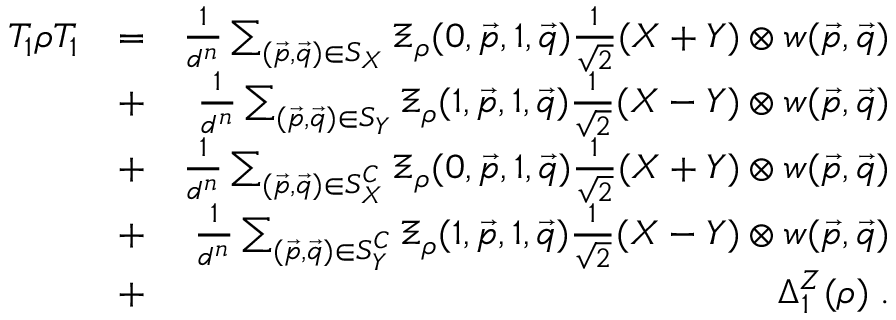<formula> <loc_0><loc_0><loc_500><loc_500>\begin{array} { r l r } { T _ { 1 } \rho T _ { 1 } } & { = } & { \frac { 1 } { d ^ { n } } \sum _ { ( \vec { p } , \vec { q } ) \in S _ { X } } \Xi _ { \rho } ( 0 , \vec { p } , 1 , \vec { q } ) \frac { 1 } { \sqrt { 2 } } ( X + Y ) \otimes w ( \vec { p } , \vec { q } ) } \\ & { + } & { \frac { 1 } { d ^ { n } } \sum _ { ( \vec { p } , \vec { q } ) \in S _ { Y } } \Xi _ { \rho } ( 1 , \vec { p } , 1 , \vec { q } ) \frac { 1 } { \sqrt { 2 } } ( X - Y ) \otimes w ( \vec { p } , \vec { q } ) } \\ & { + } & { \frac { 1 } { d ^ { n } } \sum _ { ( \vec { p } , \vec { q } ) \in S _ { X } ^ { C } } \Xi _ { \rho } ( 0 , \vec { p } , 1 , \vec { q } ) \frac { 1 } { \sqrt { 2 } } ( X + Y ) \otimes w ( \vec { p } , \vec { q } ) } \\ & { + } & { \frac { 1 } { d ^ { n } } \sum _ { ( \vec { p } , \vec { q } ) \in S _ { Y } ^ { C } } \Xi _ { \rho } ( 1 , \vec { p } , 1 , \vec { q } ) \frac { 1 } { \sqrt { 2 } } ( X - Y ) \otimes w ( \vec { p } , \vec { q } ) } \\ & { + } & { \Delta _ { 1 } ^ { Z } ( \rho ) \, . } \end{array}</formula> 